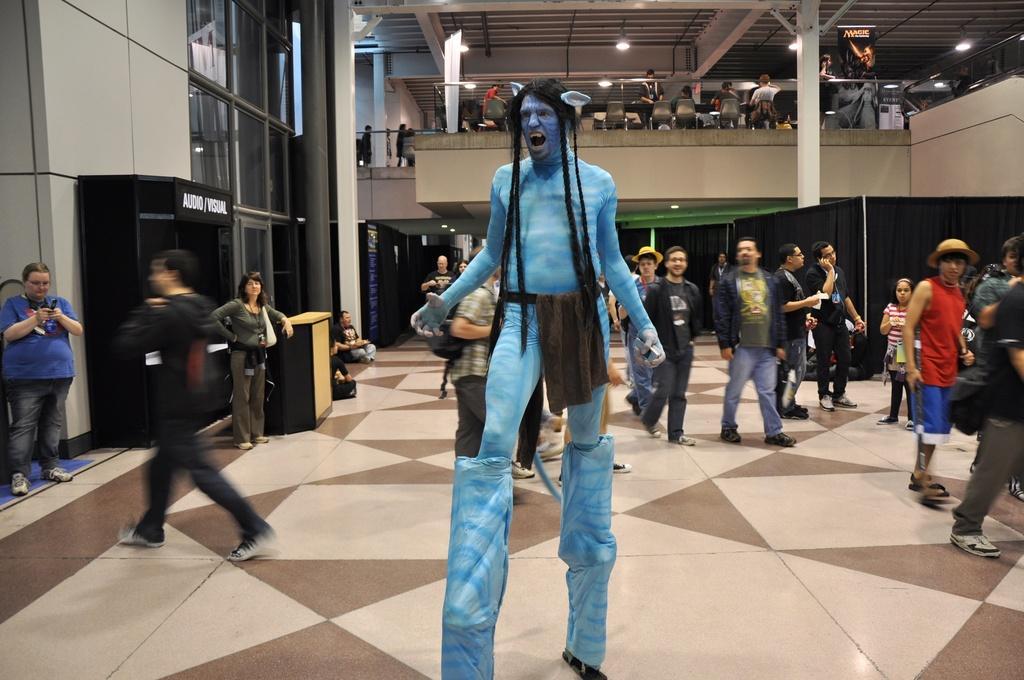Can you describe this image briefly? This picture describes about group of people, few are standing, few are walking and few are seated on the chairs, and we can see a man in the middle of the image, he wore costumes, in the background we can find few lights and hoardings, and also we can see few curtains. 